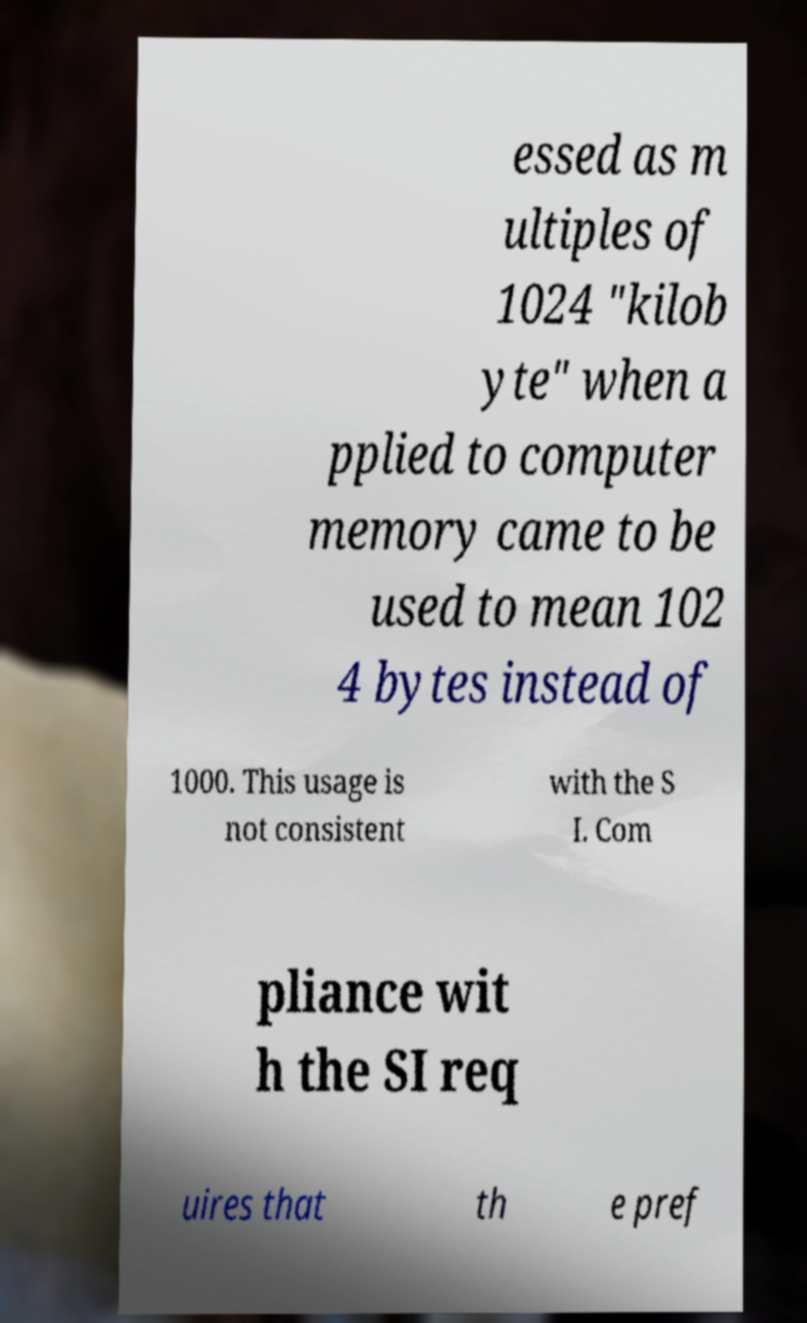Could you extract and type out the text from this image? essed as m ultiples of 1024 "kilob yte" when a pplied to computer memory came to be used to mean 102 4 bytes instead of 1000. This usage is not consistent with the S I. Com pliance wit h the SI req uires that th e pref 